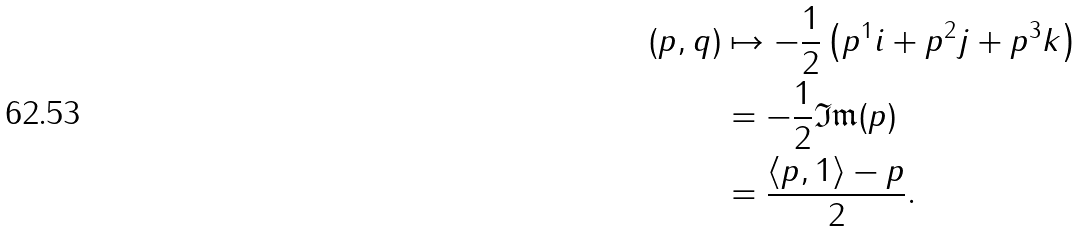<formula> <loc_0><loc_0><loc_500><loc_500>\left ( p , q \right ) & \mapsto - \frac { 1 } { 2 } \left ( p ^ { 1 } i + p ^ { 2 } j + p ^ { 3 } k \right ) \\ & = - \frac { 1 } { 2 } \mathfrak { I m } ( p ) \\ & = \frac { \left < p , 1 \right > - p } { 2 } .</formula> 